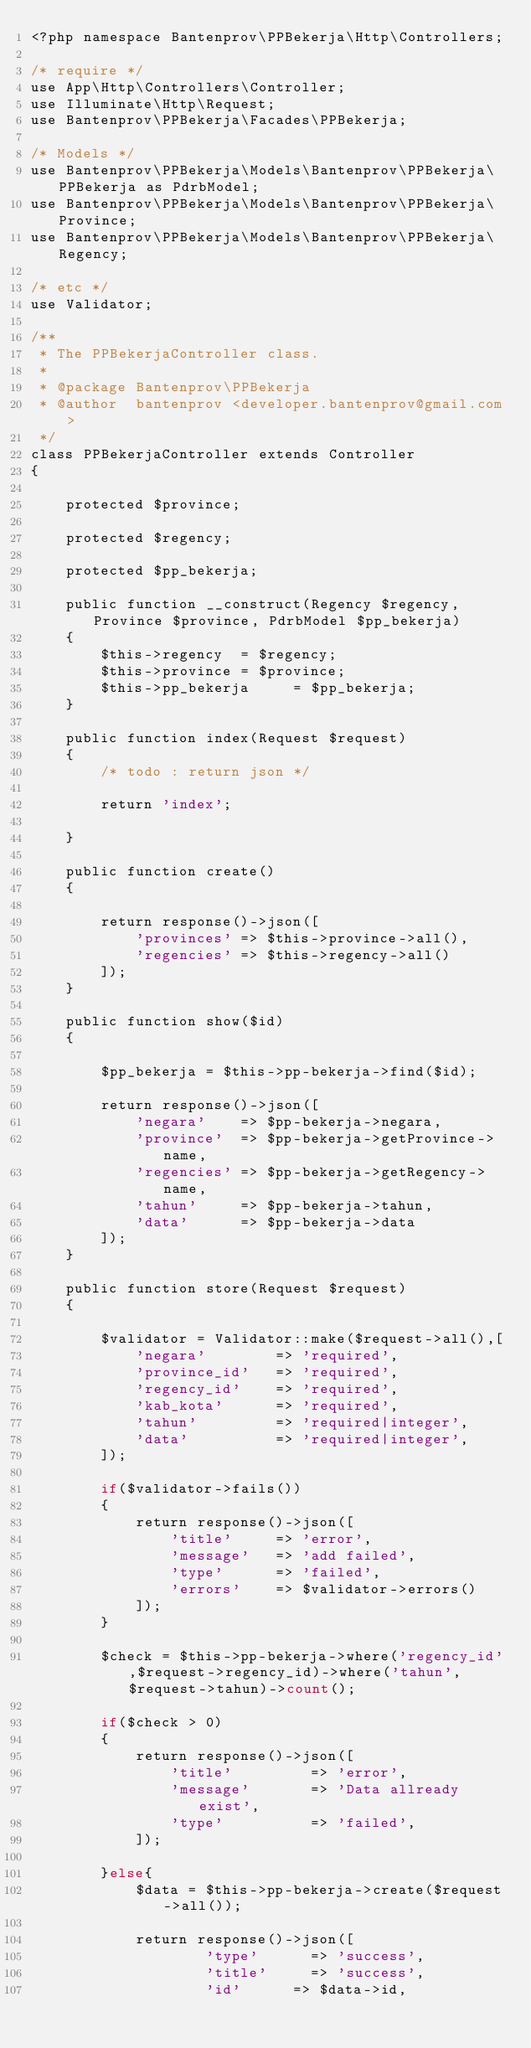<code> <loc_0><loc_0><loc_500><loc_500><_PHP_><?php namespace Bantenprov\PPBekerja\Http\Controllers;

/* require */
use App\Http\Controllers\Controller;
use Illuminate\Http\Request;
use Bantenprov\PPBekerja\Facades\PPBekerja;

/* Models */
use Bantenprov\PPBekerja\Models\Bantenprov\PPBekerja\PPBekerja as PdrbModel;
use Bantenprov\PPBekerja\Models\Bantenprov\PPBekerja\Province;
use Bantenprov\PPBekerja\Models\Bantenprov\PPBekerja\Regency;

/* etc */
use Validator;

/**
 * The PPBekerjaController class.
 *
 * @package Bantenprov\PPBekerja
 * @author  bantenprov <developer.bantenprov@gmail.com>
 */
class PPBekerjaController extends Controller
{

    protected $province;

    protected $regency;

    protected $pp_bekerja;

    public function __construct(Regency $regency, Province $province, PdrbModel $pp_bekerja)
    {
        $this->regency  = $regency;
        $this->province = $province;
        $this->pp_bekerja     = $pp_bekerja;
    }

    public function index(Request $request)
    {
        /* todo : return json */

        return 'index';

    }

    public function create()
    {

        return response()->json([
            'provinces' => $this->province->all(),
            'regencies' => $this->regency->all()
        ]);
    }

    public function show($id)
    {

        $pp_bekerja = $this->pp-bekerja->find($id);

        return response()->json([
            'negara'    => $pp-bekerja->negara,
            'province'  => $pp-bekerja->getProvince->name,
            'regencies' => $pp-bekerja->getRegency->name,
            'tahun'     => $pp-bekerja->tahun,
            'data'      => $pp-bekerja->data
        ]);
    }

    public function store(Request $request)
    {

        $validator = Validator::make($request->all(),[
            'negara'        => 'required',
            'province_id'   => 'required',
            'regency_id'    => 'required',
            'kab_kota'      => 'required',
            'tahun'         => 'required|integer',
            'data'          => 'required|integer',
        ]);

        if($validator->fails())
        {
            return response()->json([
                'title'     => 'error',
                'message'   => 'add failed',
                'type'      => 'failed',
                'errors'    => $validator->errors()
            ]);
        }

        $check = $this->pp-bekerja->where('regency_id',$request->regency_id)->where('tahun',$request->tahun)->count();

        if($check > 0)
        {
            return response()->json([
                'title'         => 'error',
                'message'       => 'Data allready exist',
                'type'          => 'failed',
            ]);

        }else{
            $data = $this->pp-bekerja->create($request->all());

            return response()->json([
                    'type'      => 'success',
                    'title'     => 'success',
                    'id'      => $data->id,</code> 